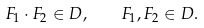<formula> <loc_0><loc_0><loc_500><loc_500>F _ { 1 } \cdot F _ { 2 } \in { D } , \quad F _ { 1 } , F _ { 2 } \in { D } .</formula> 